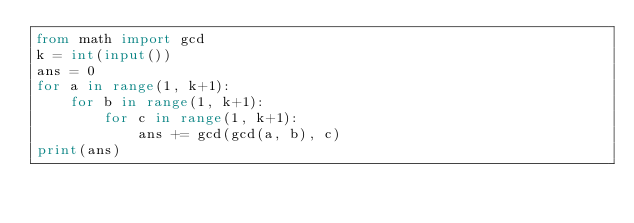<code> <loc_0><loc_0><loc_500><loc_500><_Python_>from math import gcd
k = int(input())
ans = 0
for a in range(1, k+1):
    for b in range(1, k+1):
        for c in range(1, k+1):
            ans += gcd(gcd(a, b), c)
print(ans)</code> 